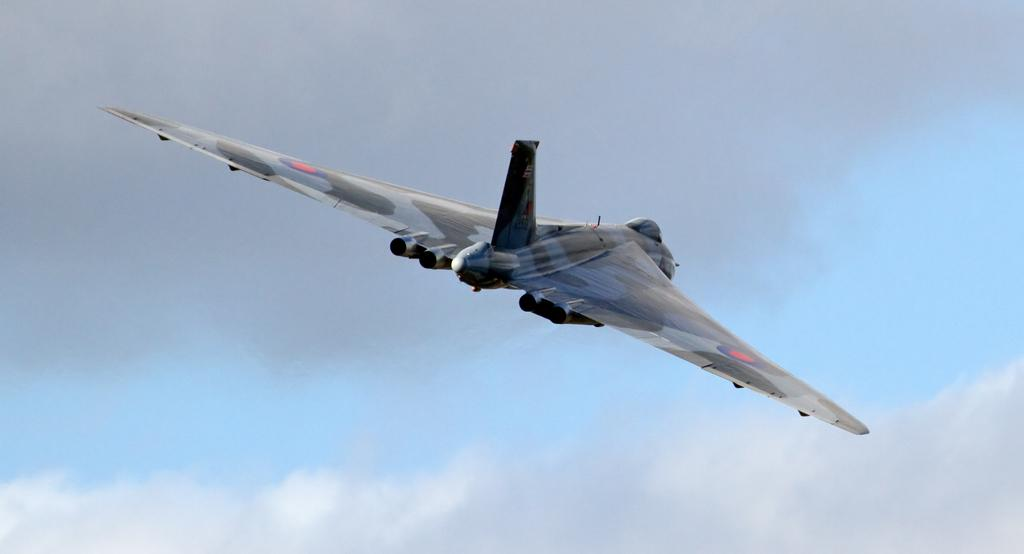What is the main subject of the image? The main subject of the image is a flying jet. How would you describe the sky in the image? The sky is cloudy and pale blue. What type of teaching method is being demonstrated in the image? There is no teaching method present in the image; it features a flying jet and a cloudy, pale blue sky. What is the reaction of the jet to the reward in the image? There is no reward present in the image, as it only features a flying jet and a cloudy, pale blue sky. 